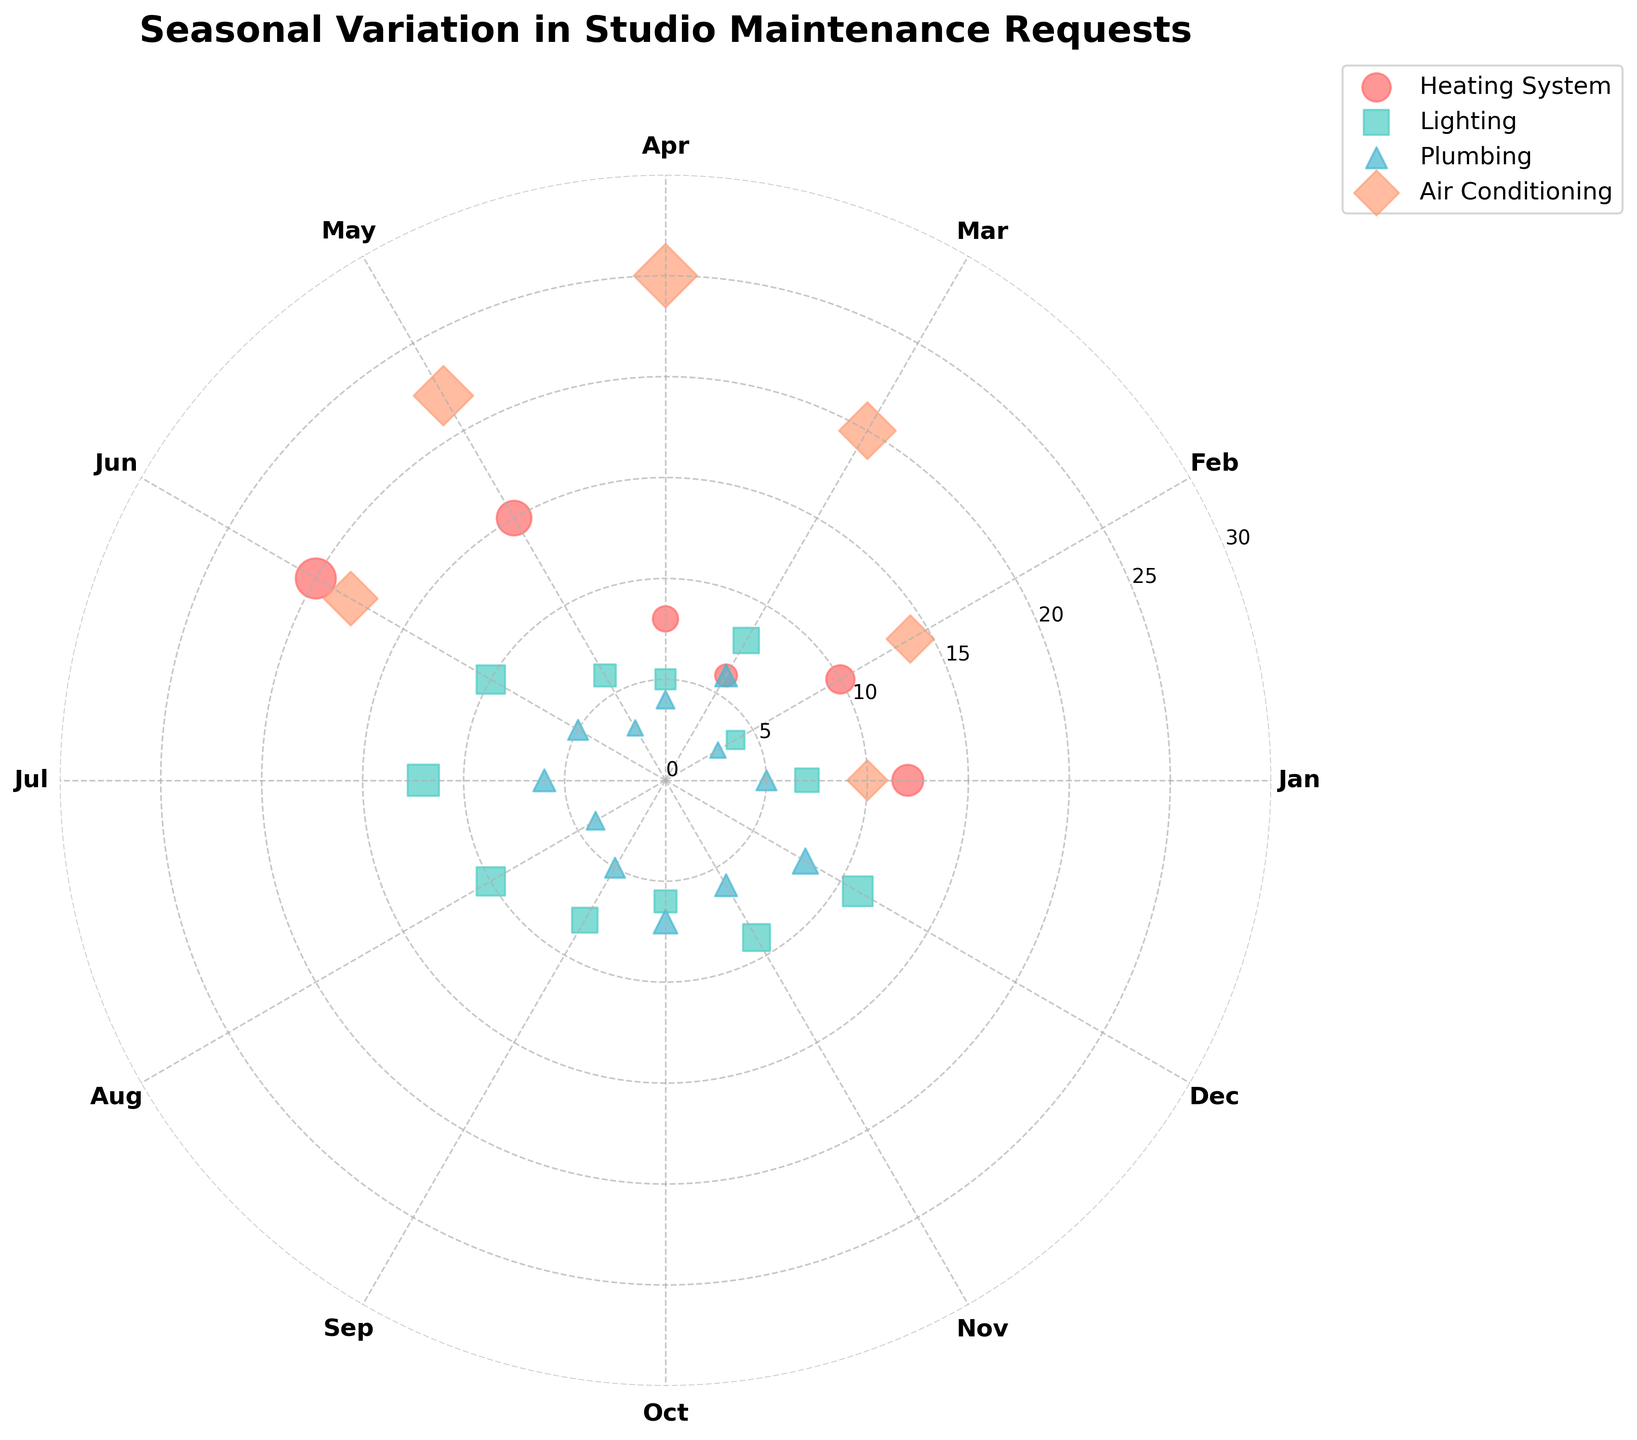What is the title of the chart? The title of the chart is usually placed at the top of the figure. In this case, it reads "Seasonal Variation in Studio Maintenance Requests".
Answer: Seasonal Variation in Studio Maintenance Requests What type of maintenance had the highest number of requests in July? By observing the scatter points on the polar chart in the segment labeled 'Jul', you can see that Air Conditioning has the largest scatter point in July.
Answer: Air Conditioning How many requests were made for Heating System in December? Locate the December segment on the polar chart, then find the scatter point corresponding to the Heating System. The radius of this point indicates the number of requests.
Answer: 20 Which month had the highest number of air conditioning requests? By looking at the scatter points associated with Air Conditioning across all months, the one with the largest radius will indicate the month with the highest number. In this case, July shows the highest number of requests.
Answer: July During which months were the requests for plumbing lower than 5? Look at the plumbing scatter points across all months on the polar chart. The months where the radius is less than 5 indicate fewer than 5 requests. These months are February, April, May, and August.
Answer: February, April, May, August Compare heating system requests in January and November. Which month had more requests? Look at the scatter points for Heating System in both January and November. Compare their radii; January has 12 requests while November has 15. November has more requests.
Answer: November What are the different types of maintenance issues represented in the chart? Examine the legend provided in the chart to identify the different colors and markers used. The types of maintenance issues indicated are Heating System, Lighting, Plumbing, and Air Conditioning.
Answer: Heating System, Lighting, Plumbing, Air Conditioning How do the lighting requests change from January to December? Observing the scatter points for Lighting from January to December, you can see that the number of requests starts at 7 in January, with some fluctuations across the months, and reaches 11 in December.
Answer: Increase from 7 to 11 Which type of maintenance had the most consistent number of requests across the year? View the scatter points for each type of maintenance. Lighting appears to have the smallest variability in radius across the months, indicating a more consistent number of requests.
Answer: Lighting In which month did plumbing requests peak? Look at the plumbing scatter points for each month. The largest radius represents the peak, which occurs in October with 7 requests.
Answer: October 